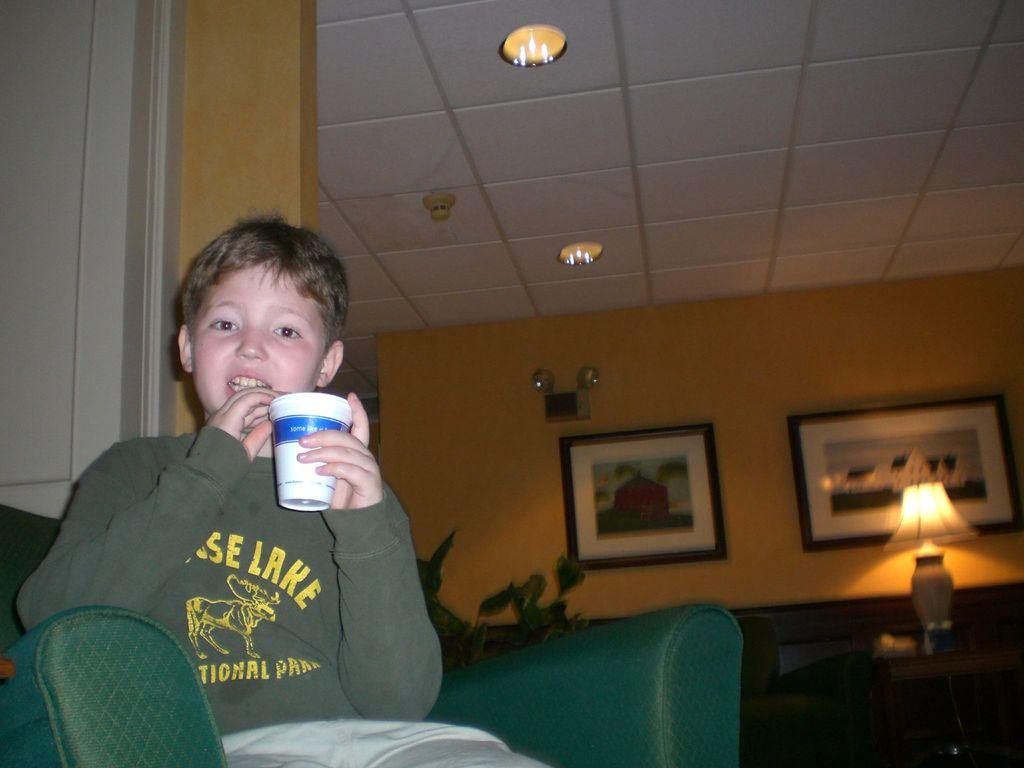Where is the boy located in the image? The boy is sitting on the sofa on the left side of the image. What is the boy wearing in the image? The boy is wearing a t-shirt in the image. What is the boy holding in his hands? The boy is holding a glass in his hands. What can be seen on the right side of the image? There is a lamp on the right side of the image. What is hanging on the wall in the image? There are photo frames on the wall in the image. Can you see any geese wearing a yoke in the image? No, there are no geese or yokes present in the image. 